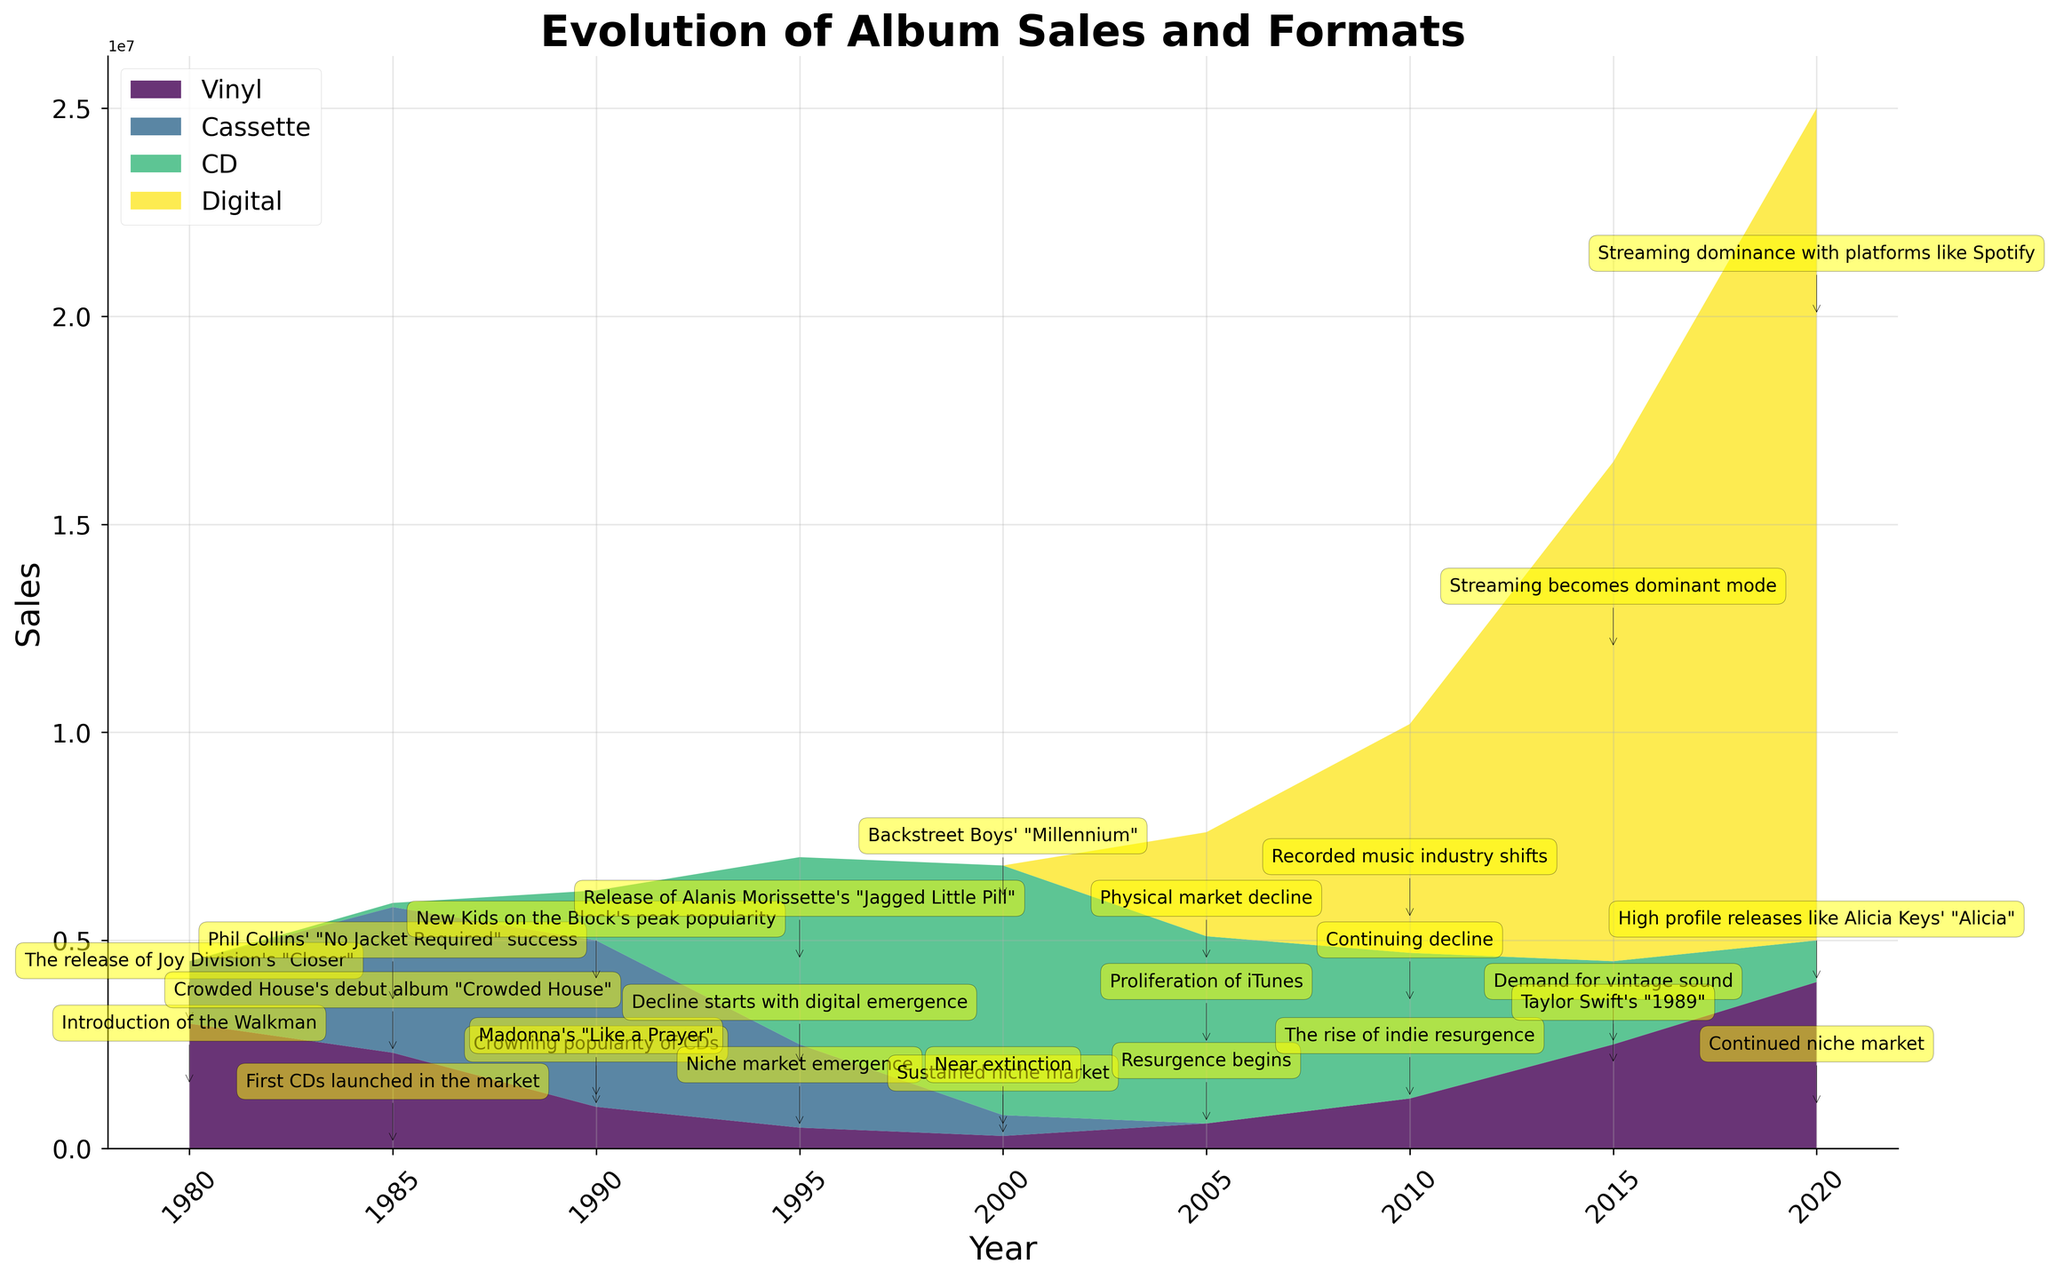What is the title of the figure? The title of the figure is usually located at the top of the plot and provides a summary of what the graph is about.
Answer: Evolution of Album Sales and Formats Which year shows the highest sales for Digital format? To determine the year with the highest Digital format sales, identify the peak value on the plot line for Digital and note its corresponding year on the X-axis.
Answer: 2020 How did CD sales change from 1995 to 2000? Look at the CD sales data points for 1995 and 2000. Observe the height of the CD area for these years and determine if it increased or decreased.
Answer: Increased What is the milestone associated with the year 1985 for vinyl sales? Find the 1985 point in the graph under the Vinyl section and read the associated milestone annotation.
Answer: Crowded House's debut album "Crowded House" Which format had the lowest sales in 2000? Identify the sales figures of Vinyl, Cassette, and CD for the year 2000 and compare their heights to find the lowest one.
Answer: Vinyl Compare the sales trends of Vinyl and Digital formats between 2010 and 2020. Identify the sales data for both formats across these years. Observe their respective growth patterns and determine if they increased, decreased, or remained constant.
Answer: Vinyl increased, Digital increased What happened to the Cassette format by the year 2000? Look at the Cassette sales for the year 2000 and compare with previous years to understand the trend. Note any significant milestone annotations as well.
Answer: Near extinction Which year did CDs first launch in the market and what were their sales? Locate the year with the annotation mentioning the first CD launched and read the sales value for that year.
Answer: 1985, 100,000 sales What caused the resurgence of Vinyl sales beginning in 2005? Find the annotation for the milestone in 2005 within the Vinyl section and read the provided context.
Answer: Resurgence begins In which year did cassette sales peak and what milestone is noted for that year? Find the highest point of Cassette sales and cross reference with the milestone annotation for that year.
Answer: 1990, New Kids on the Block's peak popularity 